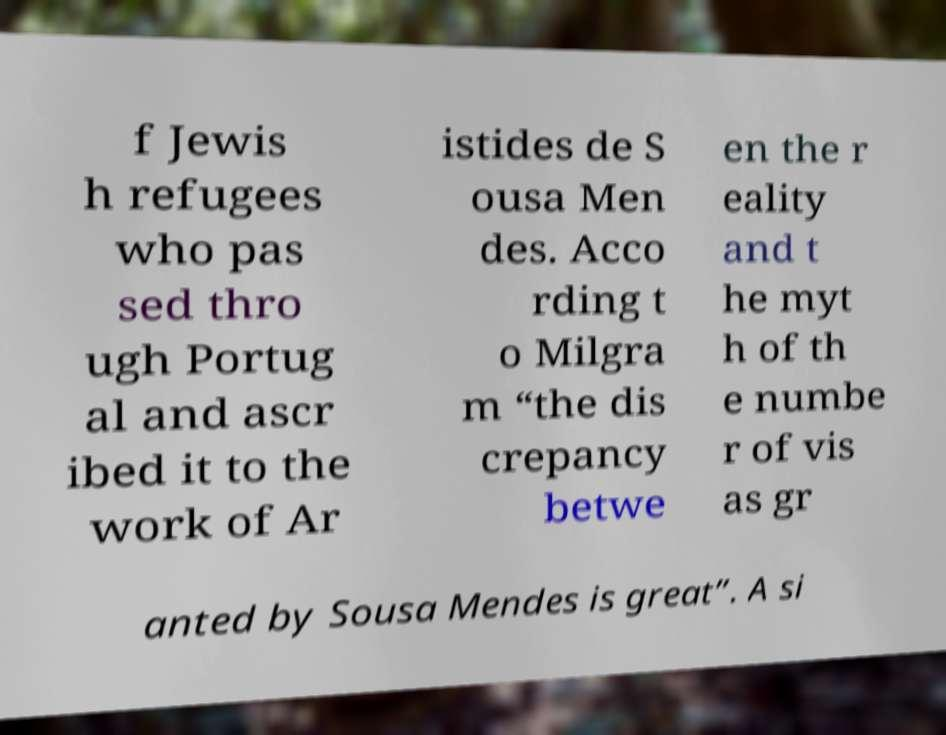Could you extract and type out the text from this image? f Jewis h refugees who pas sed thro ugh Portug al and ascr ibed it to the work of Ar istides de S ousa Men des. Acco rding t o Milgra m “the dis crepancy betwe en the r eality and t he myt h of th e numbe r of vis as gr anted by Sousa Mendes is great”. A si 